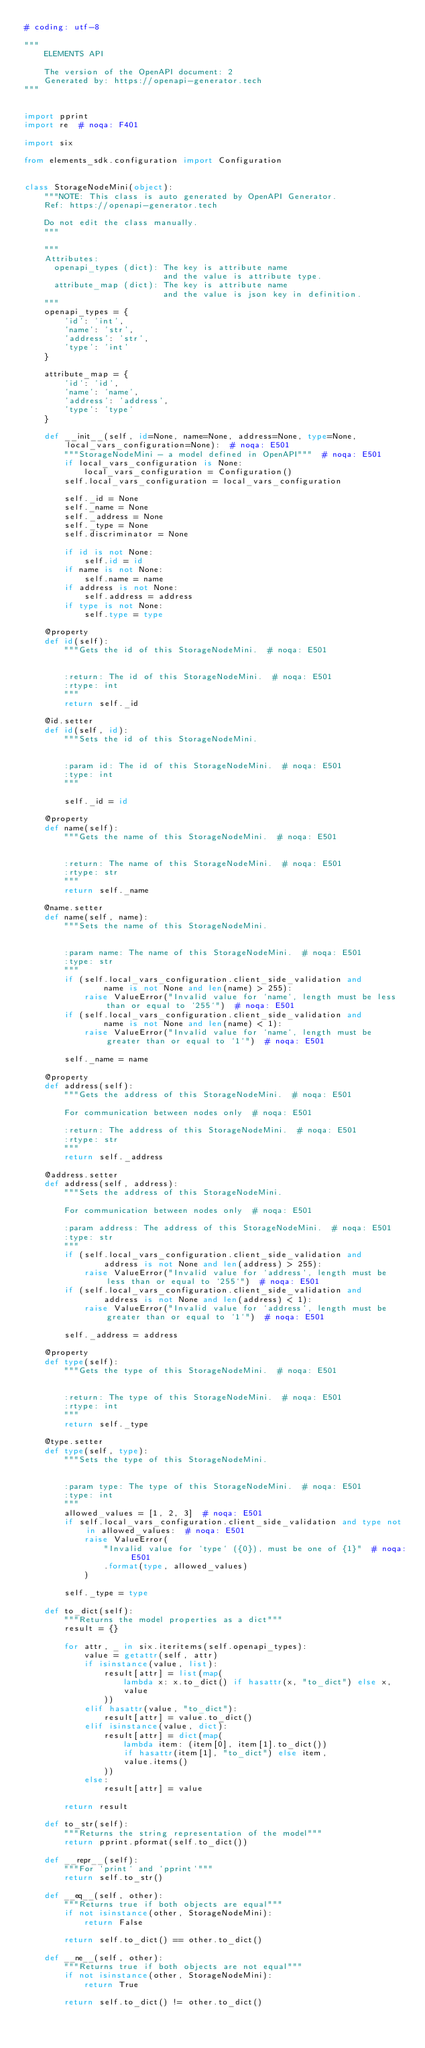Convert code to text. <code><loc_0><loc_0><loc_500><loc_500><_Python_># coding: utf-8

"""
    ELEMENTS API

    The version of the OpenAPI document: 2
    Generated by: https://openapi-generator.tech
"""


import pprint
import re  # noqa: F401

import six

from elements_sdk.configuration import Configuration


class StorageNodeMini(object):
    """NOTE: This class is auto generated by OpenAPI Generator.
    Ref: https://openapi-generator.tech

    Do not edit the class manually.
    """

    """
    Attributes:
      openapi_types (dict): The key is attribute name
                            and the value is attribute type.
      attribute_map (dict): The key is attribute name
                            and the value is json key in definition.
    """
    openapi_types = {
        'id': 'int',
        'name': 'str',
        'address': 'str',
        'type': 'int'
    }

    attribute_map = {
        'id': 'id',
        'name': 'name',
        'address': 'address',
        'type': 'type'
    }

    def __init__(self, id=None, name=None, address=None, type=None, local_vars_configuration=None):  # noqa: E501
        """StorageNodeMini - a model defined in OpenAPI"""  # noqa: E501
        if local_vars_configuration is None:
            local_vars_configuration = Configuration()
        self.local_vars_configuration = local_vars_configuration

        self._id = None
        self._name = None
        self._address = None
        self._type = None
        self.discriminator = None

        if id is not None:
            self.id = id
        if name is not None:
            self.name = name
        if address is not None:
            self.address = address
        if type is not None:
            self.type = type

    @property
    def id(self):
        """Gets the id of this StorageNodeMini.  # noqa: E501


        :return: The id of this StorageNodeMini.  # noqa: E501
        :rtype: int
        """
        return self._id

    @id.setter
    def id(self, id):
        """Sets the id of this StorageNodeMini.


        :param id: The id of this StorageNodeMini.  # noqa: E501
        :type: int
        """

        self._id = id

    @property
    def name(self):
        """Gets the name of this StorageNodeMini.  # noqa: E501


        :return: The name of this StorageNodeMini.  # noqa: E501
        :rtype: str
        """
        return self._name

    @name.setter
    def name(self, name):
        """Sets the name of this StorageNodeMini.


        :param name: The name of this StorageNodeMini.  # noqa: E501
        :type: str
        """
        if (self.local_vars_configuration.client_side_validation and
                name is not None and len(name) > 255):
            raise ValueError("Invalid value for `name`, length must be less than or equal to `255`")  # noqa: E501
        if (self.local_vars_configuration.client_side_validation and
                name is not None and len(name) < 1):
            raise ValueError("Invalid value for `name`, length must be greater than or equal to `1`")  # noqa: E501

        self._name = name

    @property
    def address(self):
        """Gets the address of this StorageNodeMini.  # noqa: E501

        For communication between nodes only  # noqa: E501

        :return: The address of this StorageNodeMini.  # noqa: E501
        :rtype: str
        """
        return self._address

    @address.setter
    def address(self, address):
        """Sets the address of this StorageNodeMini.

        For communication between nodes only  # noqa: E501

        :param address: The address of this StorageNodeMini.  # noqa: E501
        :type: str
        """
        if (self.local_vars_configuration.client_side_validation and
                address is not None and len(address) > 255):
            raise ValueError("Invalid value for `address`, length must be less than or equal to `255`")  # noqa: E501
        if (self.local_vars_configuration.client_side_validation and
                address is not None and len(address) < 1):
            raise ValueError("Invalid value for `address`, length must be greater than or equal to `1`")  # noqa: E501

        self._address = address

    @property
    def type(self):
        """Gets the type of this StorageNodeMini.  # noqa: E501


        :return: The type of this StorageNodeMini.  # noqa: E501
        :rtype: int
        """
        return self._type

    @type.setter
    def type(self, type):
        """Sets the type of this StorageNodeMini.


        :param type: The type of this StorageNodeMini.  # noqa: E501
        :type: int
        """
        allowed_values = [1, 2, 3]  # noqa: E501
        if self.local_vars_configuration.client_side_validation and type not in allowed_values:  # noqa: E501
            raise ValueError(
                "Invalid value for `type` ({0}), must be one of {1}"  # noqa: E501
                .format(type, allowed_values)
            )

        self._type = type

    def to_dict(self):
        """Returns the model properties as a dict"""
        result = {}

        for attr, _ in six.iteritems(self.openapi_types):
            value = getattr(self, attr)
            if isinstance(value, list):
                result[attr] = list(map(
                    lambda x: x.to_dict() if hasattr(x, "to_dict") else x,
                    value
                ))
            elif hasattr(value, "to_dict"):
                result[attr] = value.to_dict()
            elif isinstance(value, dict):
                result[attr] = dict(map(
                    lambda item: (item[0], item[1].to_dict())
                    if hasattr(item[1], "to_dict") else item,
                    value.items()
                ))
            else:
                result[attr] = value

        return result

    def to_str(self):
        """Returns the string representation of the model"""
        return pprint.pformat(self.to_dict())

    def __repr__(self):
        """For `print` and `pprint`"""
        return self.to_str()

    def __eq__(self, other):
        """Returns true if both objects are equal"""
        if not isinstance(other, StorageNodeMini):
            return False

        return self.to_dict() == other.to_dict()

    def __ne__(self, other):
        """Returns true if both objects are not equal"""
        if not isinstance(other, StorageNodeMini):
            return True

        return self.to_dict() != other.to_dict()
</code> 